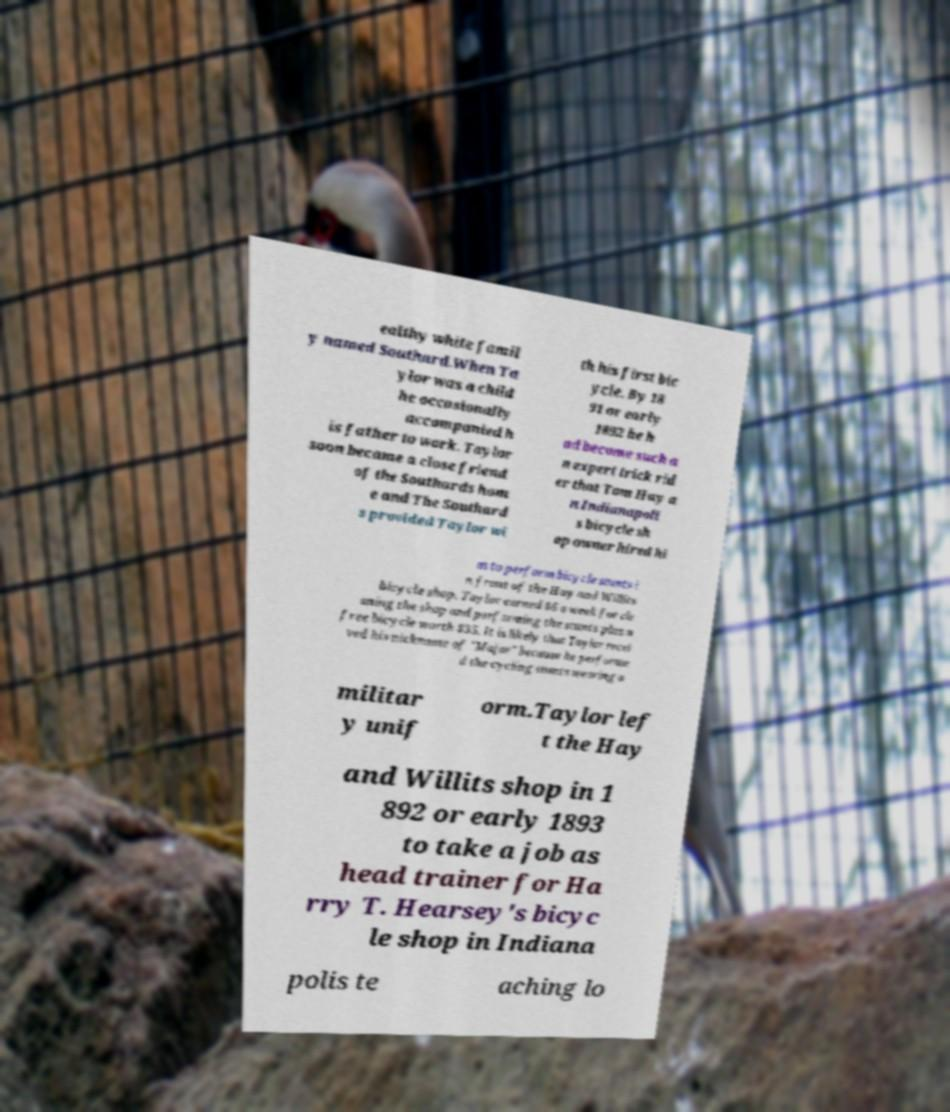Could you extract and type out the text from this image? ealthy white famil y named Southard.When Ta ylor was a child he occasionally accompanied h is father to work. Taylor soon became a close friend of the Southards hom e and The Southard s provided Taylor wi th his first bic ycle. By 18 91 or early 1892 he h ad become such a n expert trick rid er that Tom Hay a n Indianapoli s bicycle sh op owner hired hi m to perform bicycle stunts i n front of the Hay and Willits bicycle shop. Taylor earned $6 a week for cle aning the shop and performing the stunts plus a free bicycle worth $35. It is likely that Taylor recei ved his nickname of "Major" because he performe d the cycling stunts wearing a militar y unif orm.Taylor lef t the Hay and Willits shop in 1 892 or early 1893 to take a job as head trainer for Ha rry T. Hearsey's bicyc le shop in Indiana polis te aching lo 